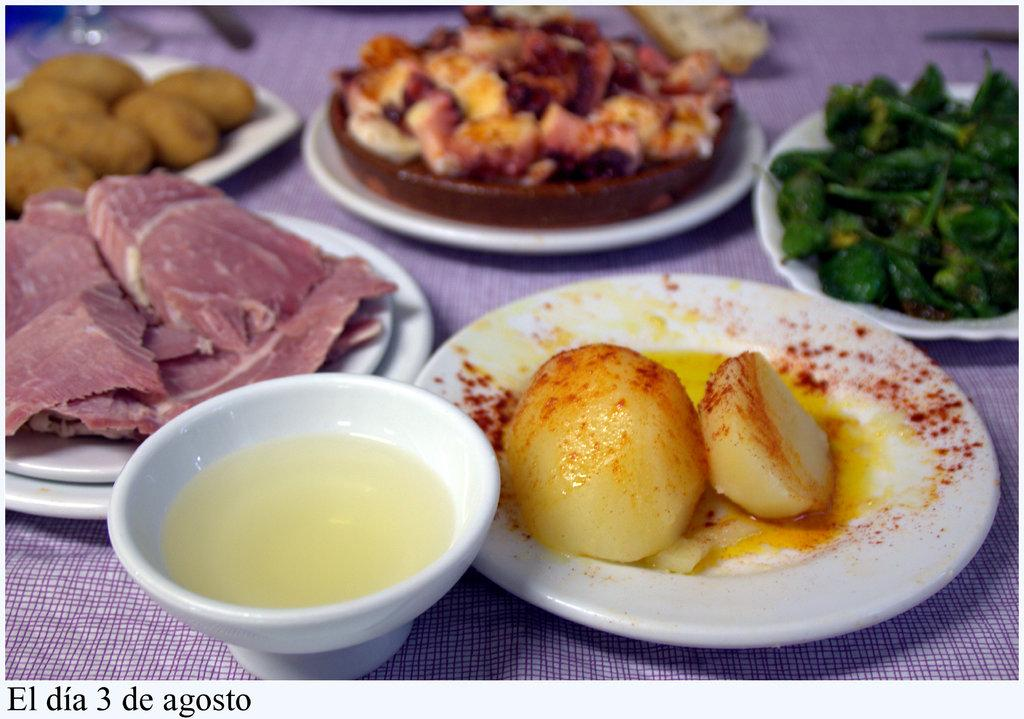What can be seen on the plates in the image? There are food items on plates in the image. What is in the bowl that is visible in the image? There is a bowl with a liquid in the image. What else is present on the table in the image? There are items on the table in the image. Is there a girl in the image who is signing an agreement with the credit card company? There is no girl or credit card company present in the image. The image only shows food items on plates, a bowl with a liquid, and items on a table. 